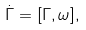<formula> <loc_0><loc_0><loc_500><loc_500>\dot { \Gamma } = [ \Gamma , \omega ] ,</formula> 